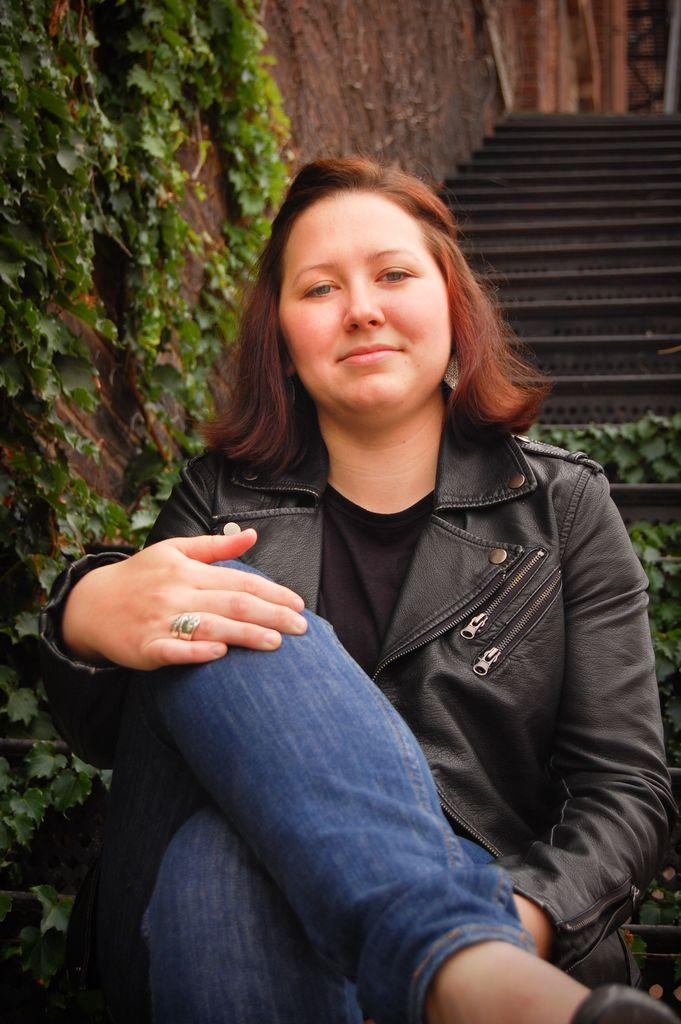What is the lady in the image doing? The lady is sitting in the image. What type of vegetation can be seen on the left side of the image? Creeper plants are visible on the left side of the image. What architectural feature is present in the background of the image? There are stairs in the background of the image. What is the background of the image composed of? There is a wall in the background of the image. What type of worm can be seen crawling on the lady's shoulder in the image? There is no worm present in the image; the lady is sitting without any visible creatures on her shoulder. 